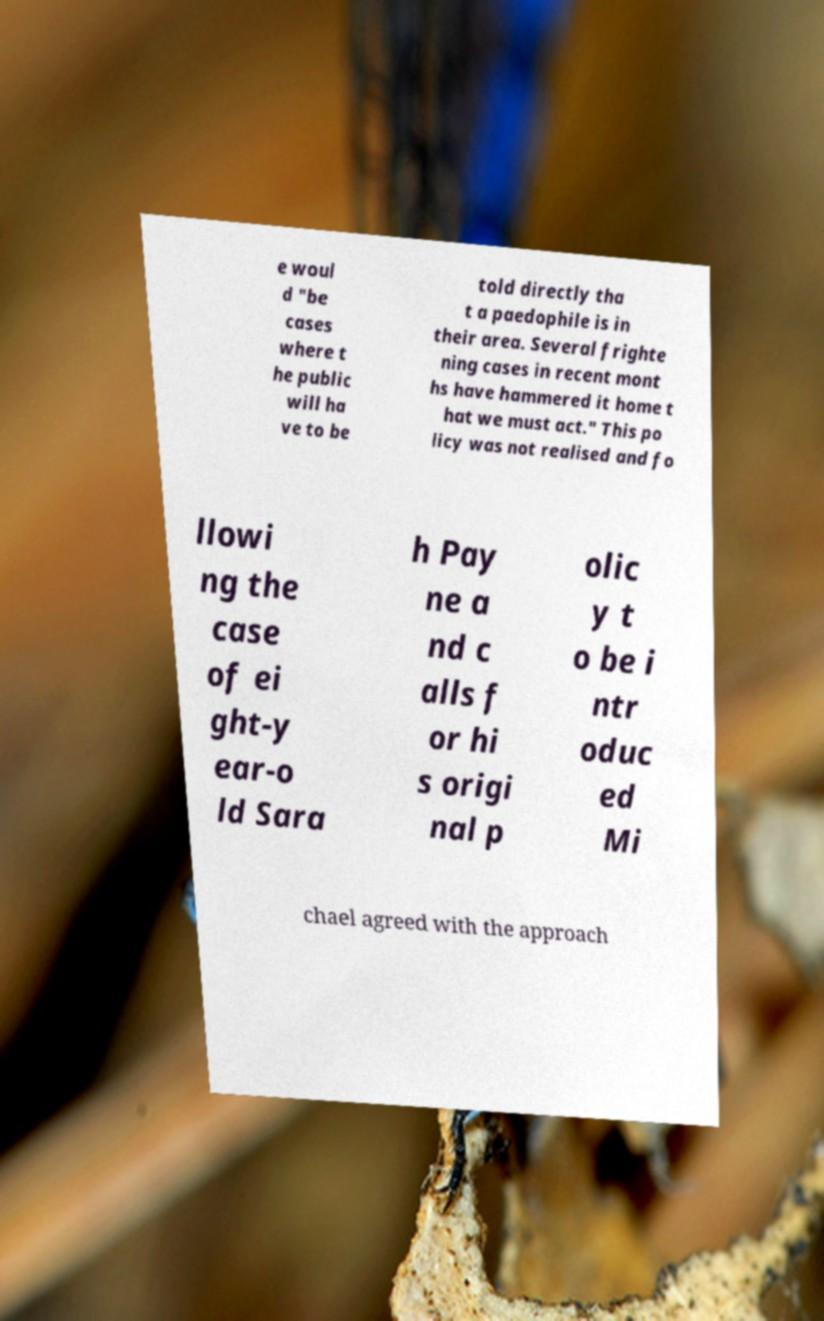Can you read and provide the text displayed in the image?This photo seems to have some interesting text. Can you extract and type it out for me? e woul d "be cases where t he public will ha ve to be told directly tha t a paedophile is in their area. Several frighte ning cases in recent mont hs have hammered it home t hat we must act." This po licy was not realised and fo llowi ng the case of ei ght-y ear-o ld Sara h Pay ne a nd c alls f or hi s origi nal p olic y t o be i ntr oduc ed Mi chael agreed with the approach 